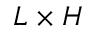<formula> <loc_0><loc_0><loc_500><loc_500>L \times H</formula> 